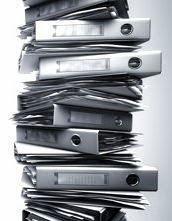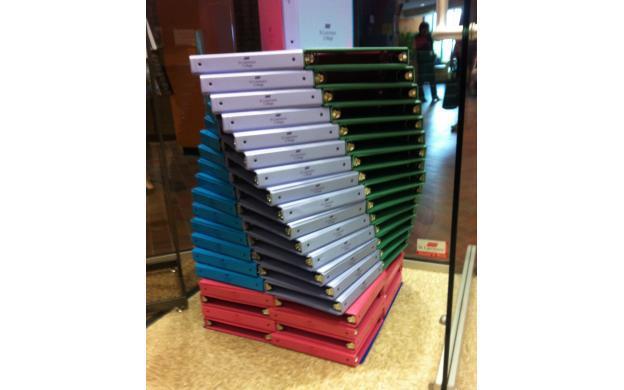The first image is the image on the left, the second image is the image on the right. Analyze the images presented: Is the assertion "At least one image shows binders stacked alternately front-to-back, with no more than seven total binders in the image." valid? Answer yes or no. No. 